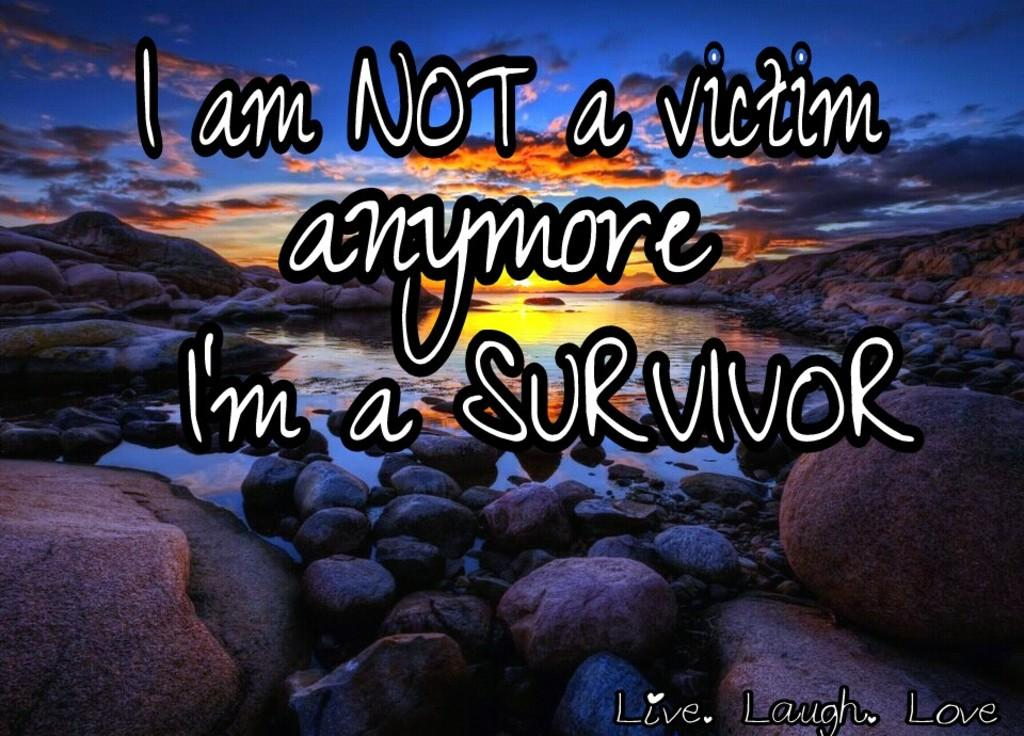<image>
Write a terse but informative summary of the picture. A sunset with the writing I am not a victim anymore, I'm a survivor. 